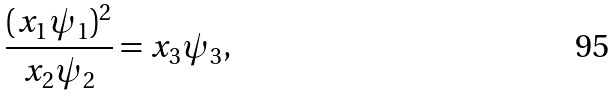Convert formula to latex. <formula><loc_0><loc_0><loc_500><loc_500>\frac { ( x _ { 1 } \psi _ { 1 } ) ^ { 2 } } { x _ { 2 } \psi _ { 2 } } = x _ { 3 } \psi _ { 3 } ,</formula> 